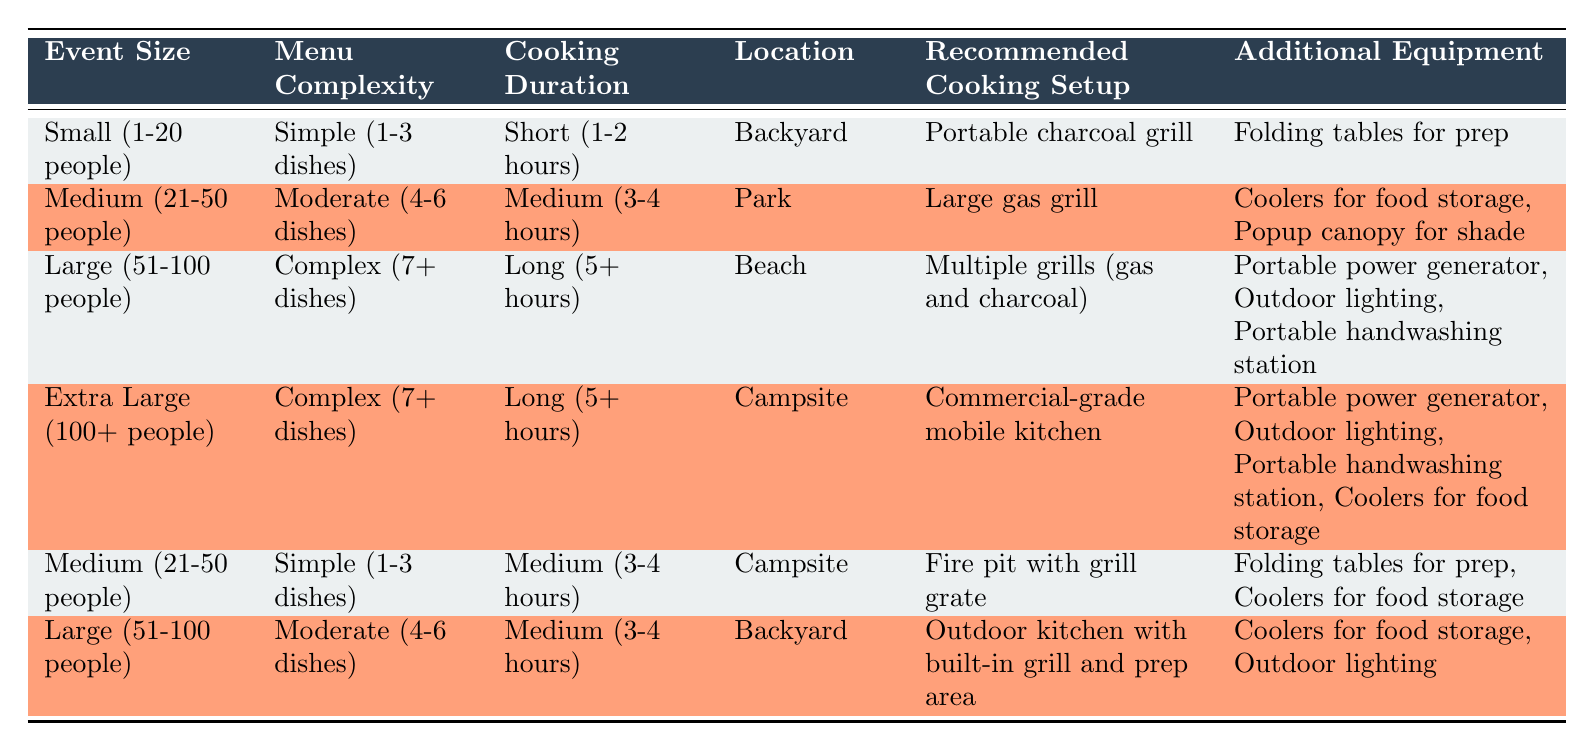What cooking setup is recommended for a small event with simple dishes in the backyard? From the table, for an event size classified as small (1-20 people) and with the menu complexity being simple (1-3 dishes), the recommended cooking setup is "Portable charcoal grill."
Answer: Portable charcoal grill Which additional equipment is suggested for a medium-sized event in a park? Looking at the table, for a medium event (21-50 people) with a moderate menu complexity (4-6 dishes) that takes a medium cooking duration (3-4 hours) in a park, the additional equipment recommended includes "Coolers for food storage" and "Popup canopy for shade."
Answer: Coolers for food storage, Popup canopy for shade Is an outdoor kitchen setup necessary for a large event with moderate menu complexity in the backyard? According to the table, a large event (51-100 people) with a moderate menu complexity (4-6 dishes) in the backyard recommends an "Outdoor kitchen with built-in grill and prep area;" thus, it is necessary for this situation.
Answer: Yes How many different cooking setups are suggested for large events? The table indicates that there are two rows for large events (51-100 people), recommending "Multiple grills (gas and charcoal)" and "Outdoor kitchen with built-in grill and prep area." Therefore, there are two different setups suggested for large events.
Answer: 2 What is the common additional equipment suggested for any complex menu? Observing the table, both complex menus (7+ dishes) for large (51-100 people) at the beach and extra-large (100+ people) at the campsite suggest additional equipment including "Portable power generator," "Outdoor lighting," and "Portable handwashing station." Both situations lead to the same additional items.
Answer: Portable power generator, Outdoor lighting, Portable handwashing station What is the recommended cooking setup for an extra-large event at a campsite? Referring to the table, the recommended cooking setup for an extra-large event (100+ people) with a complex menu (7+ dishes) requiring a long cooking duration (5+ hours) at a campsite is "Commercial-grade mobile kitchen."
Answer: Commercial-grade mobile kitchen Is a fire pit with a grill grate suited for a medium-sized event with simple dishes at a campsite? The table shows that for a medium event (21-50 people) with simple dishes (1-3 dishes) at a campsite, the recommended cooking setup is "Fire pit with grill grate," indicating that it is indeed suited for such an event.
Answer: Yes What type of additional equipment is recommended for a large event at the beach? Based on the table, for a large event (51-100 people) with complex dishes (7+ dishes) taking a long time (5+ hours) at the beach, recommended additional equipment includes "Portable power generator," "Outdoor lighting," and "Portable handwashing station."
Answer: Portable power generator, Outdoor lighting, Portable handwashing station 